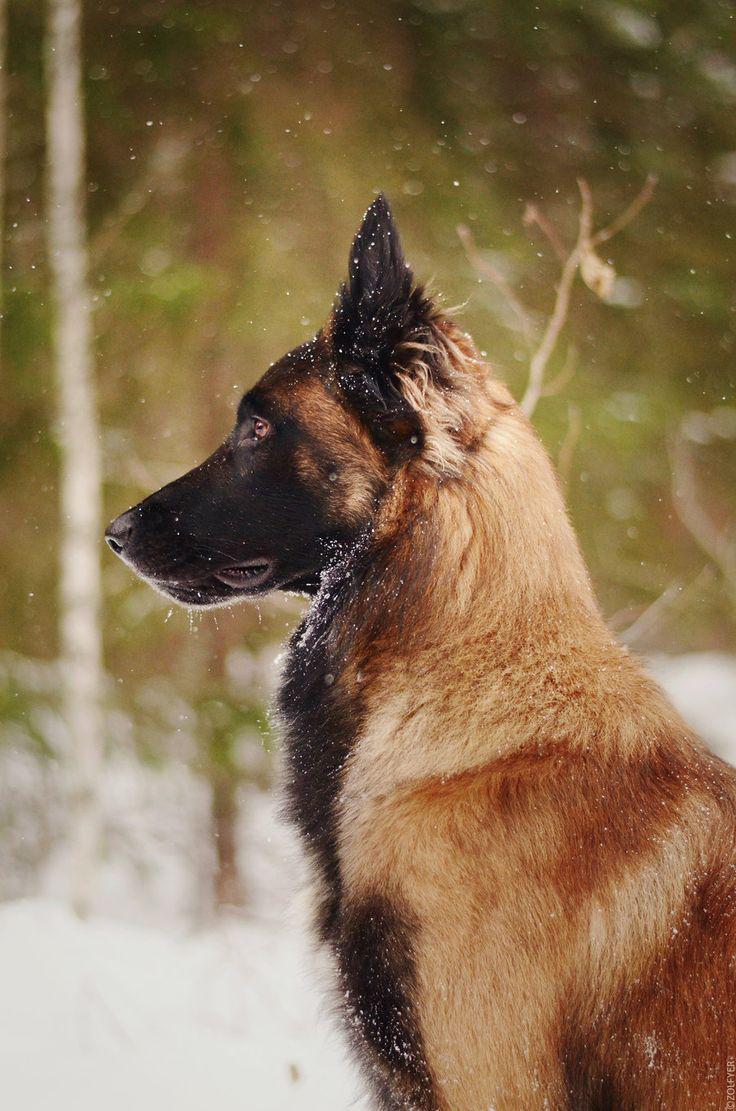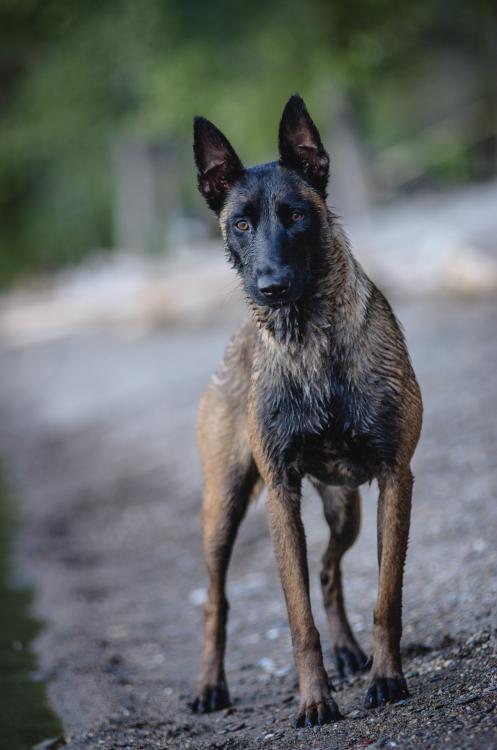The first image is the image on the left, the second image is the image on the right. Evaluate the accuracy of this statement regarding the images: "At least one dog has its tongue out.". Is it true? Answer yes or no. No. The first image is the image on the left, the second image is the image on the right. Given the left and right images, does the statement "Left image features a german shepherd sitting upright outdoors." hold true? Answer yes or no. Yes. 